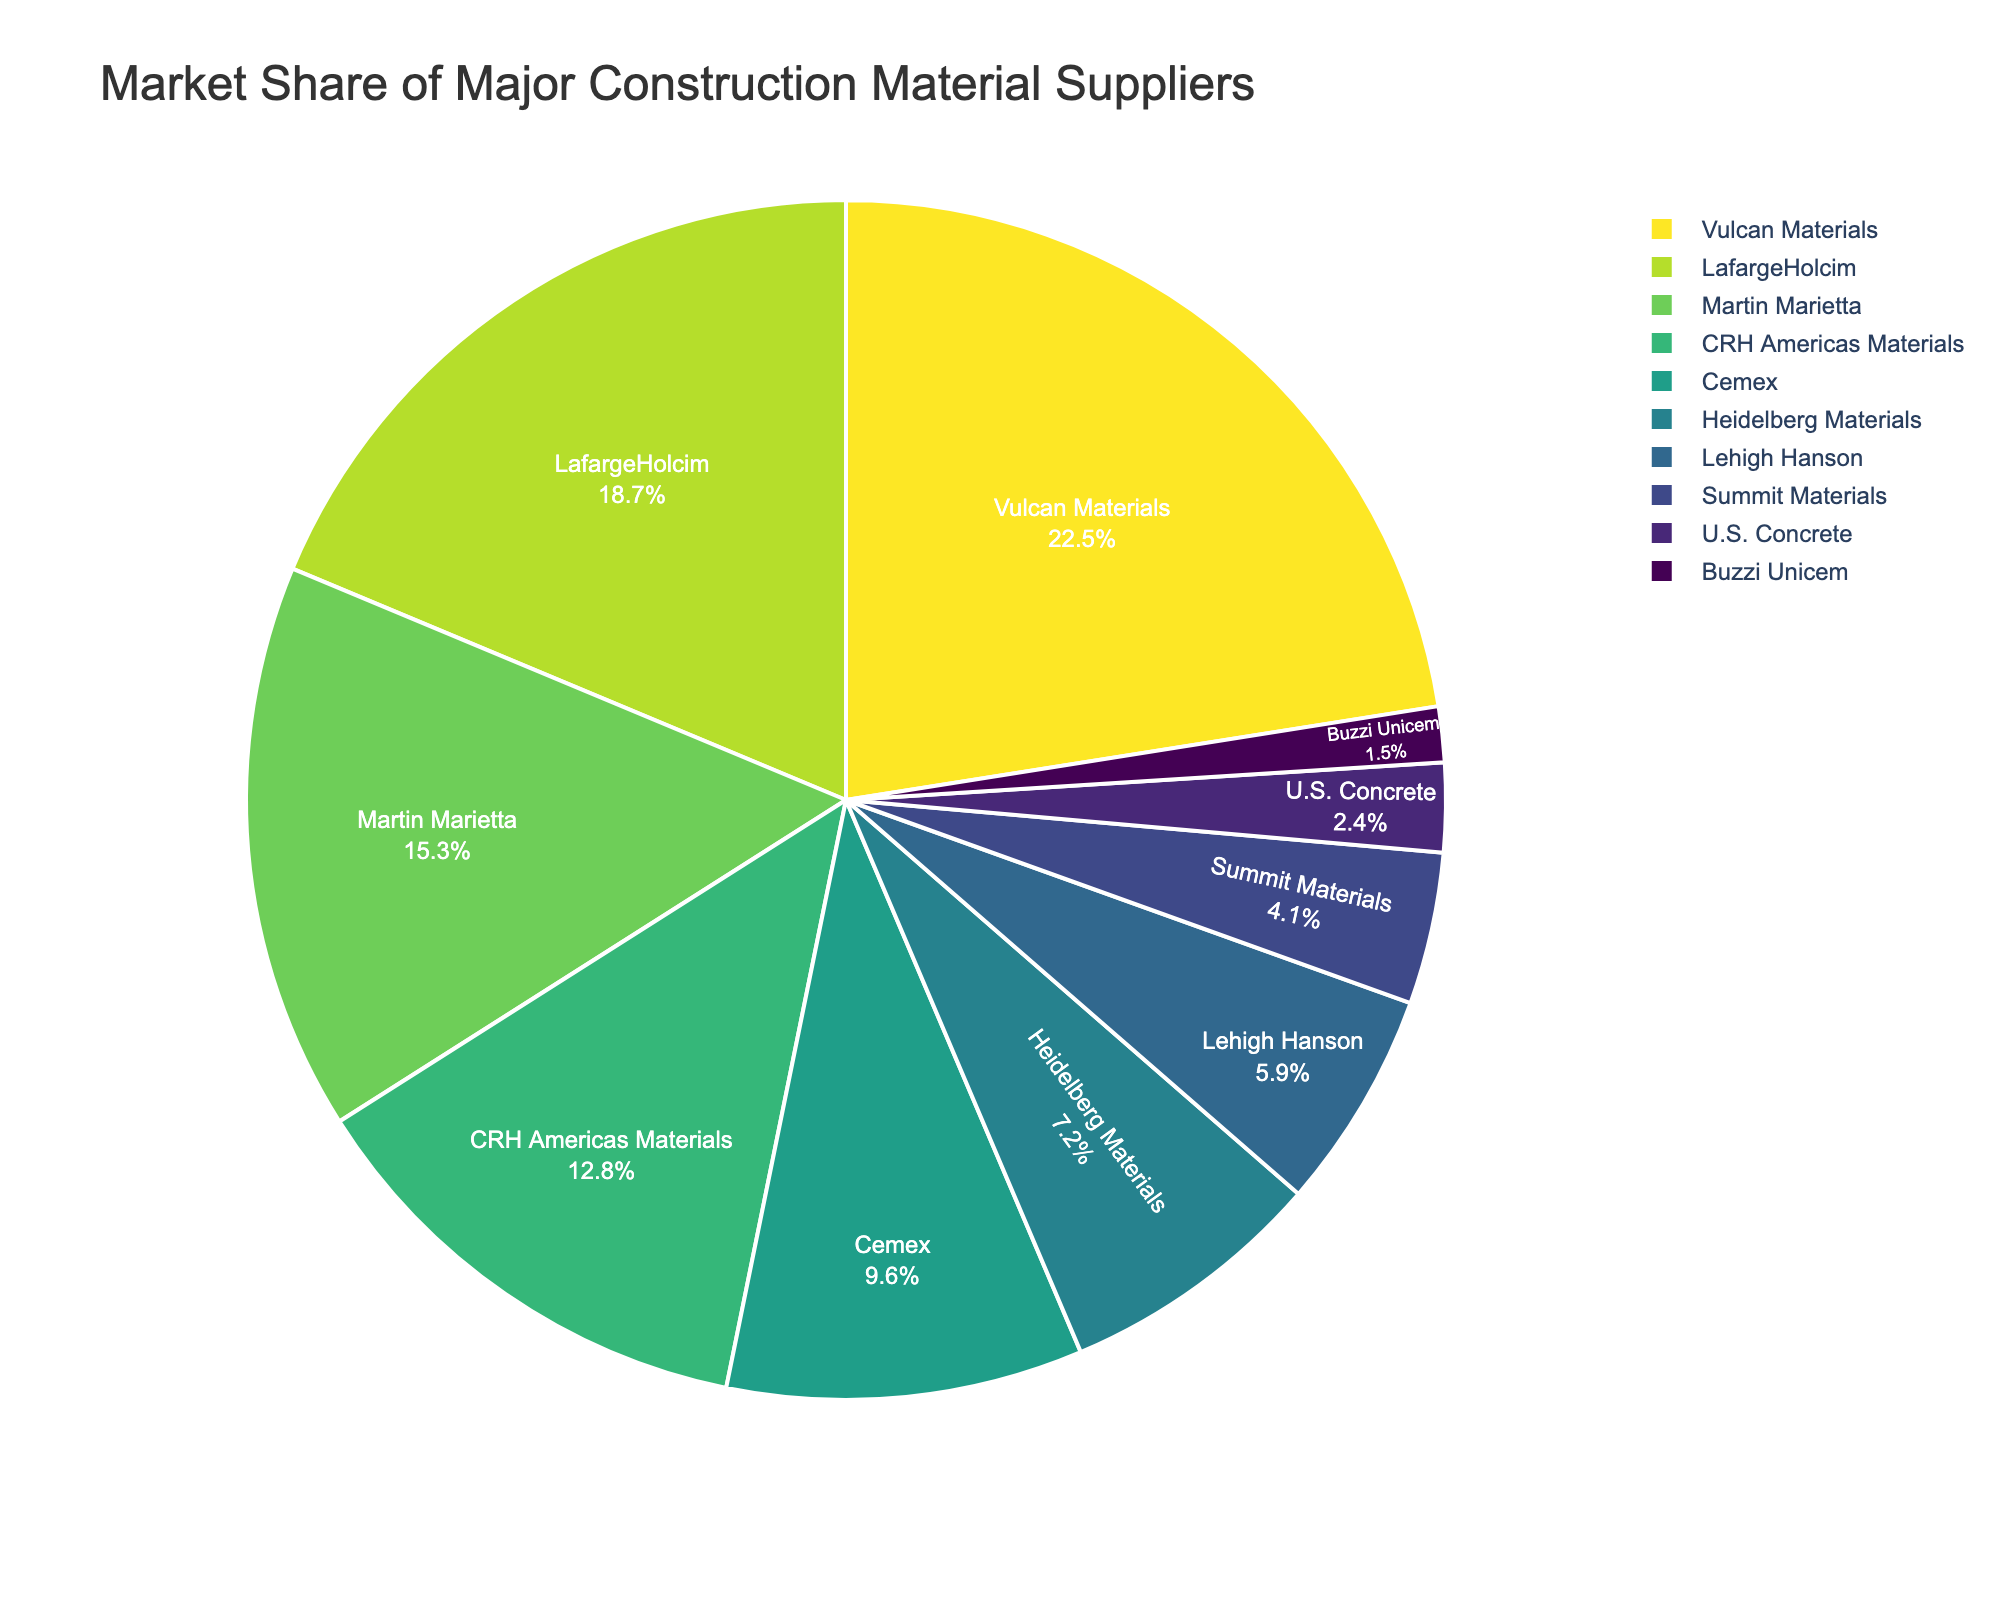What's the market share of the top three companies combined? Summing up the market shares of Vulcan Materials (22.5%), LafargeHolcim (18.7%), and Martin Marietta (15.3%) gives 22.5 + 18.7 + 15.3 = 56.5%
Answer: 56.5% Which company has the largest market share? The company with the largest market share, according to the pie chart, is Vulcan Materials with 22.5%
Answer: Vulcan Materials Which companies have a market share less than 5%? The companies with a market share less than 5% are Summit Materials (4.1%), U.S. Concrete (2.4%), and Buzzi Unicem (1.5%)
Answer: Summit Materials, U.S. Concrete, Buzzi Unicem How much larger is Vulcan Materials' market share compared to Heidelberg Materials'? Subtracting Heidelberg Materials' share from Vulcan Materials' share, we get 22.5% - 7.2% = 15.3%
Answer: 15.3% What percent of the market do companies with a market share below 10% hold altogether? Summing up the market shares of Cemex (9.6%), Heidelberg Materials (7.2%), Lehigh Hanson (5.9%), Summit Materials (4.1%), U.S. Concrete (2.4%), and Buzzi Unicem (1.5%) gives 9.6 + 7.2 + 5.9 + 4.1 + 2.4 + 1.5 = 30.7%
Answer: 30.7% Compare the market shares of LafargeHolcim and CRH Americas Materials. Which one is larger and by how much? The market share of LafargeHolcim is 18.7%, and that of CRH Americas Materials is 12.8%. Therefore, LafargeHolcim's market share is larger by 18.7% - 12.8% = 5.9%
Answer: LafargeHolcim, 5.9% What is the visual representation color of Cemex on the pie chart? Cemex is represented by a distinct slice in the color scheme used in the pie chart. According to the custom color palette that reverses the Viridis sequence, Cemex is likely represented by one of the blue shades.
Answer: Blue shade Which companies contribute to the smallest and largest market share slices on the pie chart? The largest slice corresponds to Vulcan Materials (22.5%), and the smallest slice corresponds to Buzzi Unicem (1.5%)
Answer: Vulcan Materials, Buzzi Unicem 